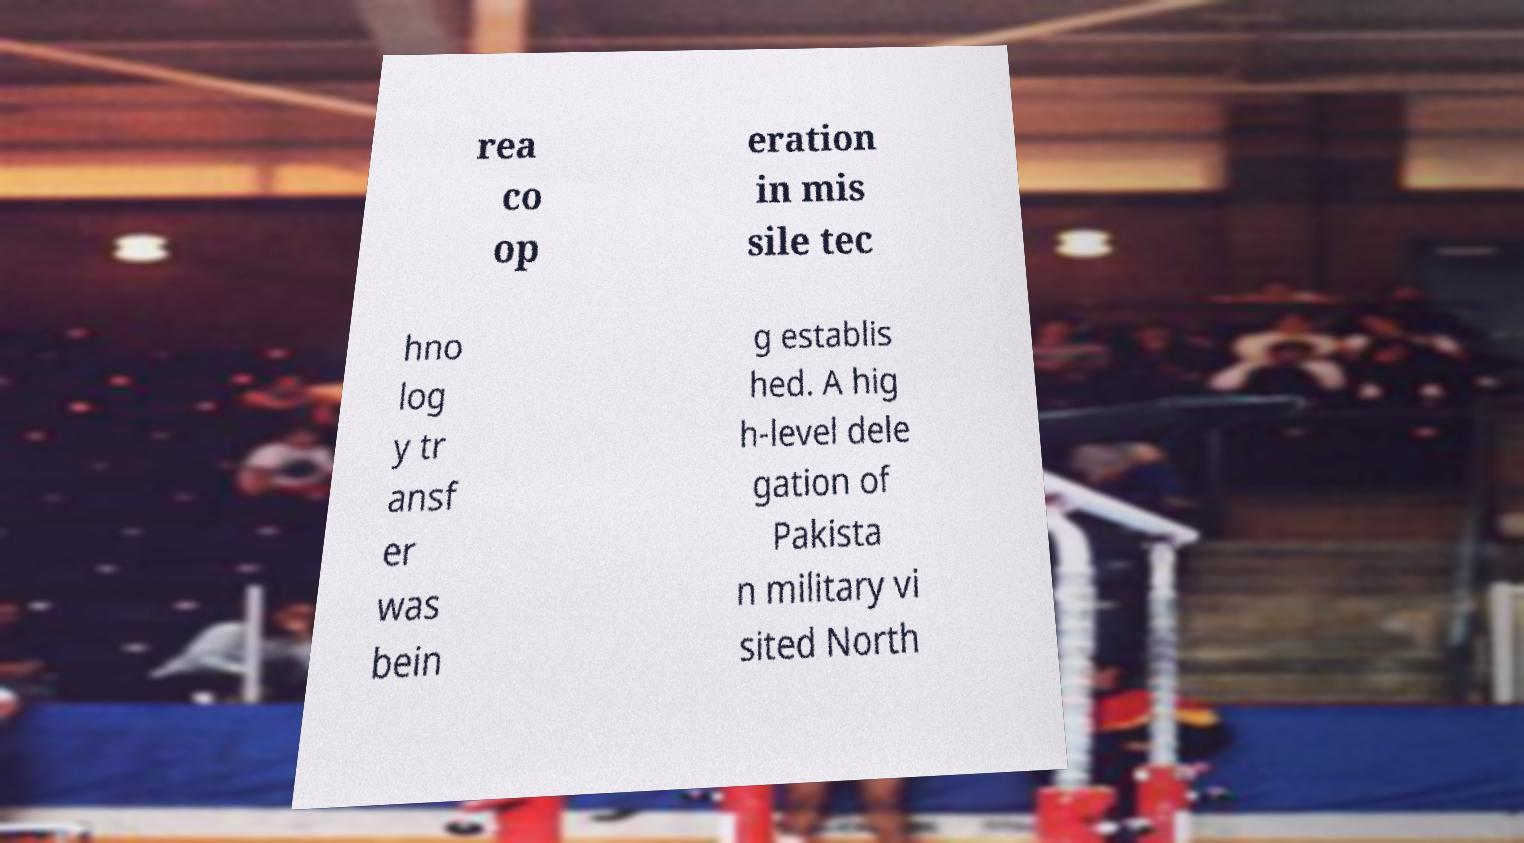For documentation purposes, I need the text within this image transcribed. Could you provide that? rea co op eration in mis sile tec hno log y tr ansf er was bein g establis hed. A hig h-level dele gation of Pakista n military vi sited North 